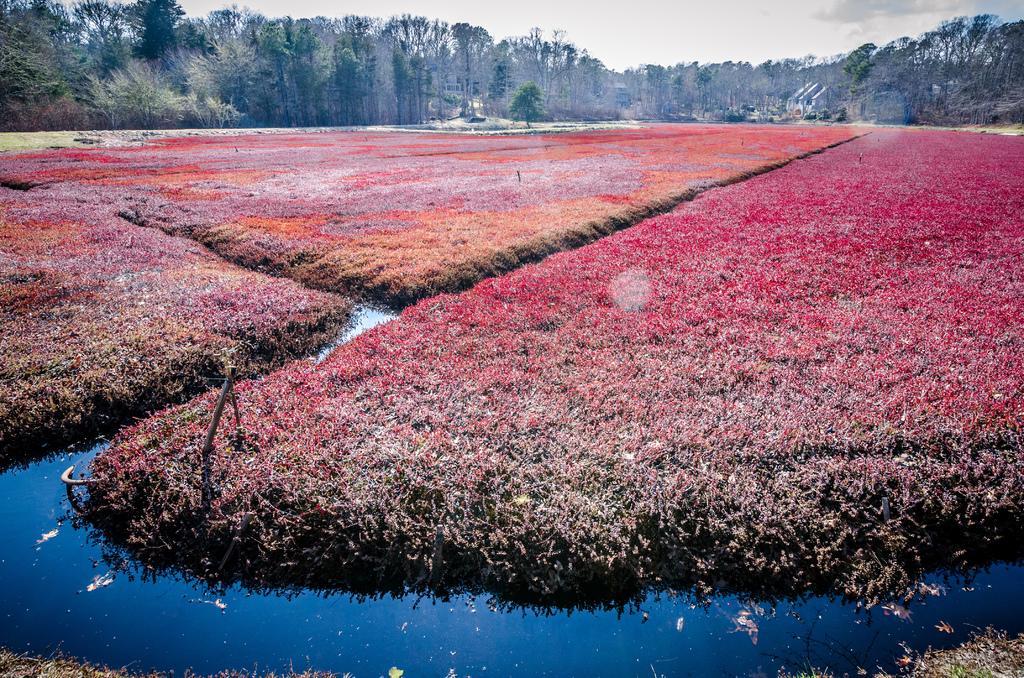Could you give a brief overview of what you see in this image? In the center of the image we can see the fields. In the background of the image we can see the trees. At the bottom of the image we can see the water. At the top of the image we can see the clouds are present in the sky. 